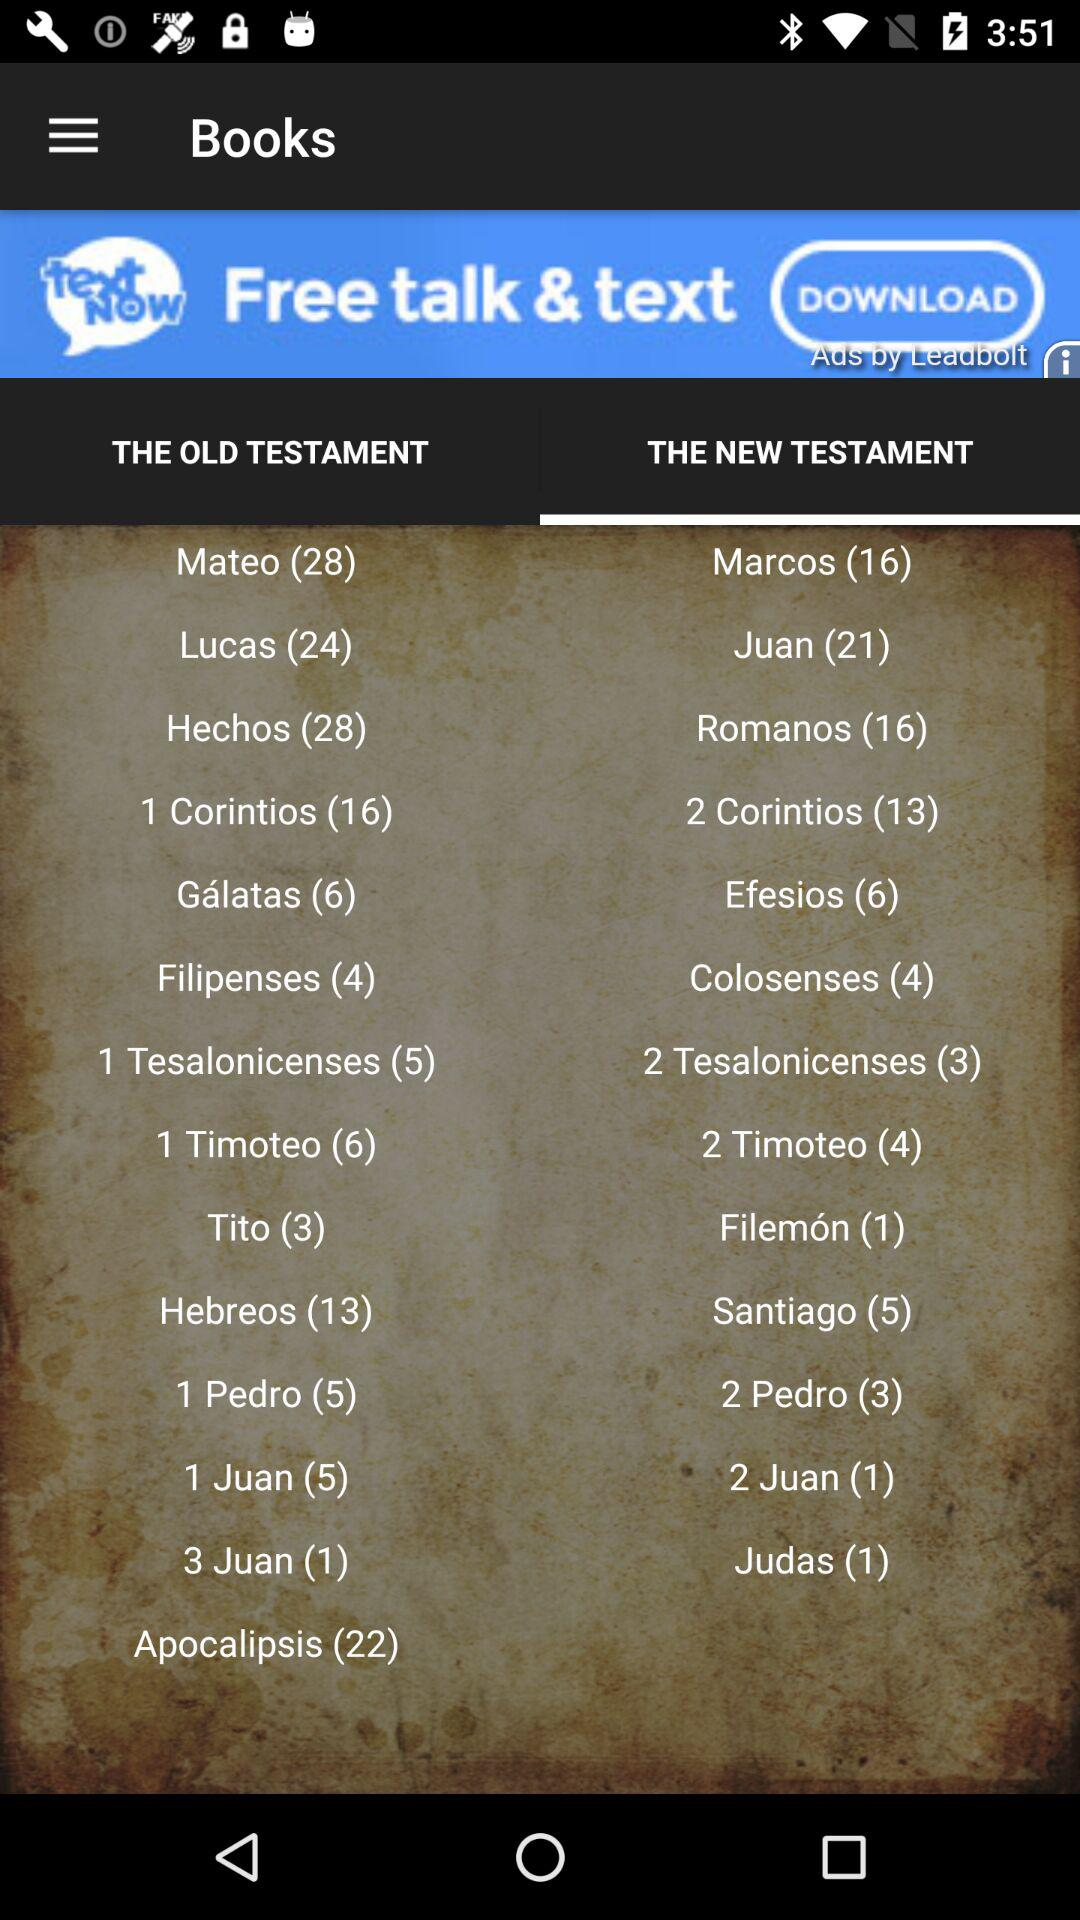How many books does Lucas contain? Lucas contains 24 books. 